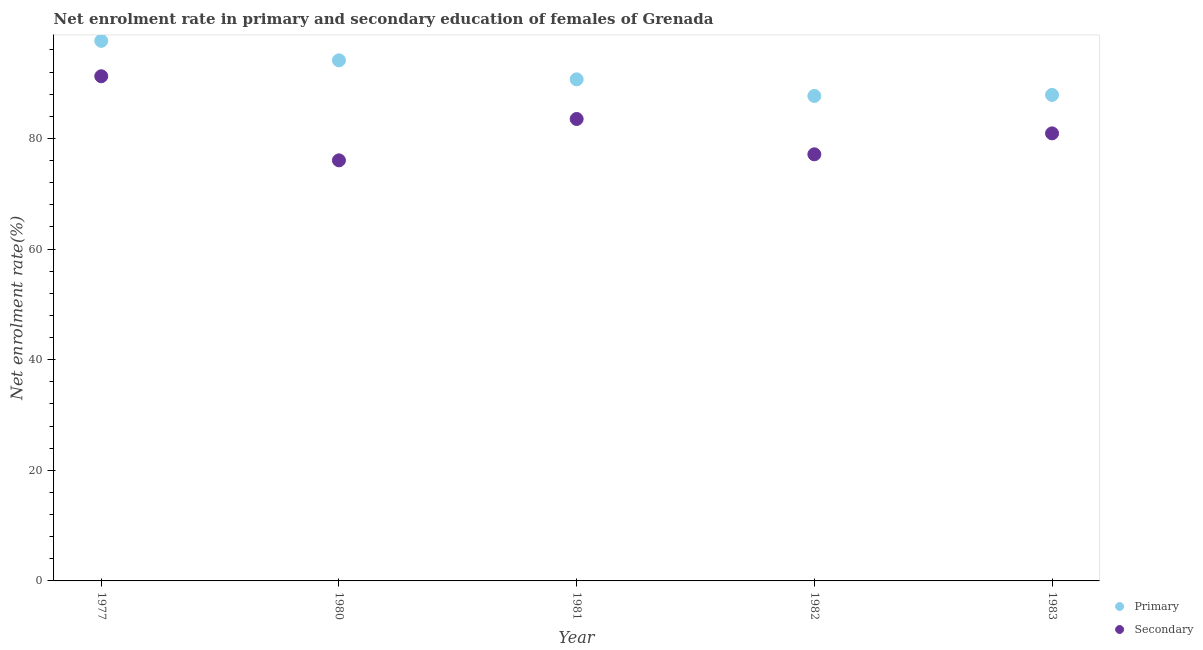How many different coloured dotlines are there?
Give a very brief answer. 2. What is the enrollment rate in primary education in 1982?
Your answer should be compact. 87.67. Across all years, what is the maximum enrollment rate in secondary education?
Offer a very short reply. 91.23. Across all years, what is the minimum enrollment rate in primary education?
Your response must be concise. 87.67. What is the total enrollment rate in primary education in the graph?
Keep it short and to the point. 457.95. What is the difference between the enrollment rate in secondary education in 1977 and that in 1982?
Your answer should be very brief. 14.11. What is the difference between the enrollment rate in primary education in 1980 and the enrollment rate in secondary education in 1977?
Make the answer very short. 2.87. What is the average enrollment rate in secondary education per year?
Offer a very short reply. 81.76. In the year 1981, what is the difference between the enrollment rate in secondary education and enrollment rate in primary education?
Make the answer very short. -7.17. What is the ratio of the enrollment rate in secondary education in 1977 to that in 1980?
Keep it short and to the point. 1.2. Is the difference between the enrollment rate in secondary education in 1981 and 1983 greater than the difference between the enrollment rate in primary education in 1981 and 1983?
Provide a succinct answer. No. What is the difference between the highest and the second highest enrollment rate in secondary education?
Your response must be concise. 7.73. What is the difference between the highest and the lowest enrollment rate in secondary education?
Give a very brief answer. 15.2. Is the sum of the enrollment rate in secondary education in 1977 and 1981 greater than the maximum enrollment rate in primary education across all years?
Offer a very short reply. Yes. Does the enrollment rate in primary education monotonically increase over the years?
Make the answer very short. No. Is the enrollment rate in secondary education strictly greater than the enrollment rate in primary education over the years?
Your answer should be very brief. No. Is the enrollment rate in primary education strictly less than the enrollment rate in secondary education over the years?
Ensure brevity in your answer.  No. How many dotlines are there?
Offer a very short reply. 2. What is the difference between two consecutive major ticks on the Y-axis?
Offer a very short reply. 20. Does the graph contain grids?
Your answer should be compact. No. Where does the legend appear in the graph?
Your response must be concise. Bottom right. How many legend labels are there?
Your response must be concise. 2. How are the legend labels stacked?
Ensure brevity in your answer.  Vertical. What is the title of the graph?
Your answer should be compact. Net enrolment rate in primary and secondary education of females of Grenada. What is the label or title of the Y-axis?
Provide a succinct answer. Net enrolment rate(%). What is the Net enrolment rate(%) of Primary in 1977?
Provide a succinct answer. 97.63. What is the Net enrolment rate(%) of Secondary in 1977?
Give a very brief answer. 91.23. What is the Net enrolment rate(%) in Primary in 1980?
Your answer should be very brief. 94.11. What is the Net enrolment rate(%) in Secondary in 1980?
Provide a succinct answer. 76.03. What is the Net enrolment rate(%) of Primary in 1981?
Give a very brief answer. 90.68. What is the Net enrolment rate(%) of Secondary in 1981?
Offer a terse response. 83.51. What is the Net enrolment rate(%) in Primary in 1982?
Make the answer very short. 87.67. What is the Net enrolment rate(%) of Secondary in 1982?
Make the answer very short. 77.12. What is the Net enrolment rate(%) of Primary in 1983?
Provide a succinct answer. 87.86. What is the Net enrolment rate(%) of Secondary in 1983?
Your response must be concise. 80.91. Across all years, what is the maximum Net enrolment rate(%) of Primary?
Keep it short and to the point. 97.63. Across all years, what is the maximum Net enrolment rate(%) in Secondary?
Your answer should be compact. 91.23. Across all years, what is the minimum Net enrolment rate(%) in Primary?
Provide a short and direct response. 87.67. Across all years, what is the minimum Net enrolment rate(%) in Secondary?
Make the answer very short. 76.03. What is the total Net enrolment rate(%) of Primary in the graph?
Provide a short and direct response. 457.95. What is the total Net enrolment rate(%) in Secondary in the graph?
Keep it short and to the point. 408.81. What is the difference between the Net enrolment rate(%) of Primary in 1977 and that in 1980?
Give a very brief answer. 3.53. What is the difference between the Net enrolment rate(%) in Secondary in 1977 and that in 1980?
Your answer should be compact. 15.2. What is the difference between the Net enrolment rate(%) in Primary in 1977 and that in 1981?
Your answer should be compact. 6.96. What is the difference between the Net enrolment rate(%) of Secondary in 1977 and that in 1981?
Your answer should be compact. 7.73. What is the difference between the Net enrolment rate(%) in Primary in 1977 and that in 1982?
Make the answer very short. 9.96. What is the difference between the Net enrolment rate(%) of Secondary in 1977 and that in 1982?
Offer a terse response. 14.11. What is the difference between the Net enrolment rate(%) of Primary in 1977 and that in 1983?
Give a very brief answer. 9.78. What is the difference between the Net enrolment rate(%) in Secondary in 1977 and that in 1983?
Your answer should be compact. 10.33. What is the difference between the Net enrolment rate(%) of Primary in 1980 and that in 1981?
Your answer should be compact. 3.43. What is the difference between the Net enrolment rate(%) of Secondary in 1980 and that in 1981?
Your answer should be very brief. -7.48. What is the difference between the Net enrolment rate(%) in Primary in 1980 and that in 1982?
Your answer should be very brief. 6.43. What is the difference between the Net enrolment rate(%) in Secondary in 1980 and that in 1982?
Your answer should be very brief. -1.09. What is the difference between the Net enrolment rate(%) of Primary in 1980 and that in 1983?
Provide a succinct answer. 6.25. What is the difference between the Net enrolment rate(%) in Secondary in 1980 and that in 1983?
Your answer should be very brief. -4.88. What is the difference between the Net enrolment rate(%) of Primary in 1981 and that in 1982?
Ensure brevity in your answer.  3. What is the difference between the Net enrolment rate(%) in Secondary in 1981 and that in 1982?
Your response must be concise. 6.39. What is the difference between the Net enrolment rate(%) in Primary in 1981 and that in 1983?
Your response must be concise. 2.82. What is the difference between the Net enrolment rate(%) of Secondary in 1981 and that in 1983?
Make the answer very short. 2.6. What is the difference between the Net enrolment rate(%) of Primary in 1982 and that in 1983?
Your answer should be compact. -0.18. What is the difference between the Net enrolment rate(%) of Secondary in 1982 and that in 1983?
Give a very brief answer. -3.79. What is the difference between the Net enrolment rate(%) in Primary in 1977 and the Net enrolment rate(%) in Secondary in 1980?
Keep it short and to the point. 21.6. What is the difference between the Net enrolment rate(%) of Primary in 1977 and the Net enrolment rate(%) of Secondary in 1981?
Give a very brief answer. 14.13. What is the difference between the Net enrolment rate(%) of Primary in 1977 and the Net enrolment rate(%) of Secondary in 1982?
Your answer should be very brief. 20.51. What is the difference between the Net enrolment rate(%) of Primary in 1977 and the Net enrolment rate(%) of Secondary in 1983?
Ensure brevity in your answer.  16.73. What is the difference between the Net enrolment rate(%) of Primary in 1980 and the Net enrolment rate(%) of Secondary in 1981?
Give a very brief answer. 10.6. What is the difference between the Net enrolment rate(%) of Primary in 1980 and the Net enrolment rate(%) of Secondary in 1982?
Give a very brief answer. 16.99. What is the difference between the Net enrolment rate(%) in Primary in 1980 and the Net enrolment rate(%) in Secondary in 1983?
Make the answer very short. 13.2. What is the difference between the Net enrolment rate(%) in Primary in 1981 and the Net enrolment rate(%) in Secondary in 1982?
Give a very brief answer. 13.56. What is the difference between the Net enrolment rate(%) in Primary in 1981 and the Net enrolment rate(%) in Secondary in 1983?
Your answer should be very brief. 9.77. What is the difference between the Net enrolment rate(%) of Primary in 1982 and the Net enrolment rate(%) of Secondary in 1983?
Make the answer very short. 6.77. What is the average Net enrolment rate(%) of Primary per year?
Make the answer very short. 91.59. What is the average Net enrolment rate(%) of Secondary per year?
Make the answer very short. 81.76. In the year 1977, what is the difference between the Net enrolment rate(%) in Primary and Net enrolment rate(%) in Secondary?
Your answer should be very brief. 6.4. In the year 1980, what is the difference between the Net enrolment rate(%) in Primary and Net enrolment rate(%) in Secondary?
Provide a succinct answer. 18.08. In the year 1981, what is the difference between the Net enrolment rate(%) of Primary and Net enrolment rate(%) of Secondary?
Provide a short and direct response. 7.17. In the year 1982, what is the difference between the Net enrolment rate(%) of Primary and Net enrolment rate(%) of Secondary?
Keep it short and to the point. 10.55. In the year 1983, what is the difference between the Net enrolment rate(%) in Primary and Net enrolment rate(%) in Secondary?
Provide a short and direct response. 6.95. What is the ratio of the Net enrolment rate(%) in Primary in 1977 to that in 1980?
Your answer should be very brief. 1.04. What is the ratio of the Net enrolment rate(%) of Primary in 1977 to that in 1981?
Ensure brevity in your answer.  1.08. What is the ratio of the Net enrolment rate(%) of Secondary in 1977 to that in 1981?
Offer a terse response. 1.09. What is the ratio of the Net enrolment rate(%) in Primary in 1977 to that in 1982?
Provide a short and direct response. 1.11. What is the ratio of the Net enrolment rate(%) of Secondary in 1977 to that in 1982?
Your answer should be compact. 1.18. What is the ratio of the Net enrolment rate(%) in Primary in 1977 to that in 1983?
Provide a short and direct response. 1.11. What is the ratio of the Net enrolment rate(%) of Secondary in 1977 to that in 1983?
Keep it short and to the point. 1.13. What is the ratio of the Net enrolment rate(%) in Primary in 1980 to that in 1981?
Keep it short and to the point. 1.04. What is the ratio of the Net enrolment rate(%) in Secondary in 1980 to that in 1981?
Keep it short and to the point. 0.91. What is the ratio of the Net enrolment rate(%) of Primary in 1980 to that in 1982?
Ensure brevity in your answer.  1.07. What is the ratio of the Net enrolment rate(%) in Secondary in 1980 to that in 1982?
Ensure brevity in your answer.  0.99. What is the ratio of the Net enrolment rate(%) in Primary in 1980 to that in 1983?
Keep it short and to the point. 1.07. What is the ratio of the Net enrolment rate(%) in Secondary in 1980 to that in 1983?
Provide a short and direct response. 0.94. What is the ratio of the Net enrolment rate(%) of Primary in 1981 to that in 1982?
Give a very brief answer. 1.03. What is the ratio of the Net enrolment rate(%) in Secondary in 1981 to that in 1982?
Keep it short and to the point. 1.08. What is the ratio of the Net enrolment rate(%) in Primary in 1981 to that in 1983?
Make the answer very short. 1.03. What is the ratio of the Net enrolment rate(%) of Secondary in 1981 to that in 1983?
Provide a short and direct response. 1.03. What is the ratio of the Net enrolment rate(%) in Primary in 1982 to that in 1983?
Provide a succinct answer. 1. What is the ratio of the Net enrolment rate(%) in Secondary in 1982 to that in 1983?
Your answer should be compact. 0.95. What is the difference between the highest and the second highest Net enrolment rate(%) in Primary?
Offer a terse response. 3.53. What is the difference between the highest and the second highest Net enrolment rate(%) of Secondary?
Give a very brief answer. 7.73. What is the difference between the highest and the lowest Net enrolment rate(%) in Primary?
Provide a succinct answer. 9.96. What is the difference between the highest and the lowest Net enrolment rate(%) of Secondary?
Ensure brevity in your answer.  15.2. 